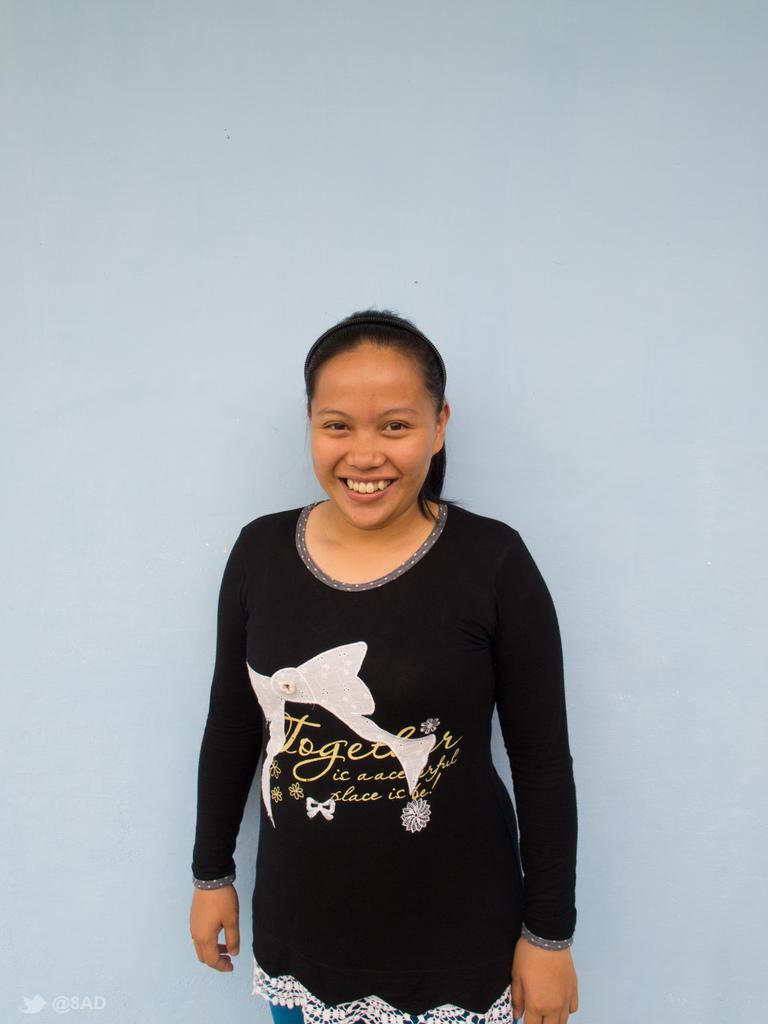Who is present in the image? There is a woman in the image. What expression does the woman have? The woman is smiling. What type of sock is the woman wearing in the image? There is no sock visible in the image, as the woman is not wearing any footwear. 